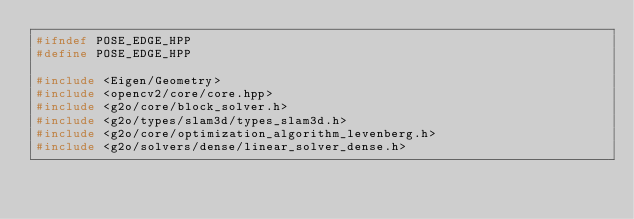Convert code to text. <code><loc_0><loc_0><loc_500><loc_500><_C++_>#ifndef POSE_EDGE_HPP
#define POSE_EDGE_HPP

#include <Eigen/Geometry>
#include <opencv2/core/core.hpp>
#include <g2o/core/block_solver.h>
#include <g2o/types/slam3d/types_slam3d.h>
#include <g2o/core/optimization_algorithm_levenberg.h>
#include <g2o/solvers/dense/linear_solver_dense.h></code> 